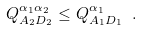Convert formula to latex. <formula><loc_0><loc_0><loc_500><loc_500>Q ^ { \alpha _ { 1 } \alpha _ { 2 } } _ { A _ { 2 } D _ { 2 } } \leq Q ^ { \alpha _ { 1 } } _ { A _ { 1 } D _ { 1 } } \ .</formula> 